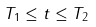Convert formula to latex. <formula><loc_0><loc_0><loc_500><loc_500>T _ { 1 } \leq t \leq T _ { 2 }</formula> 